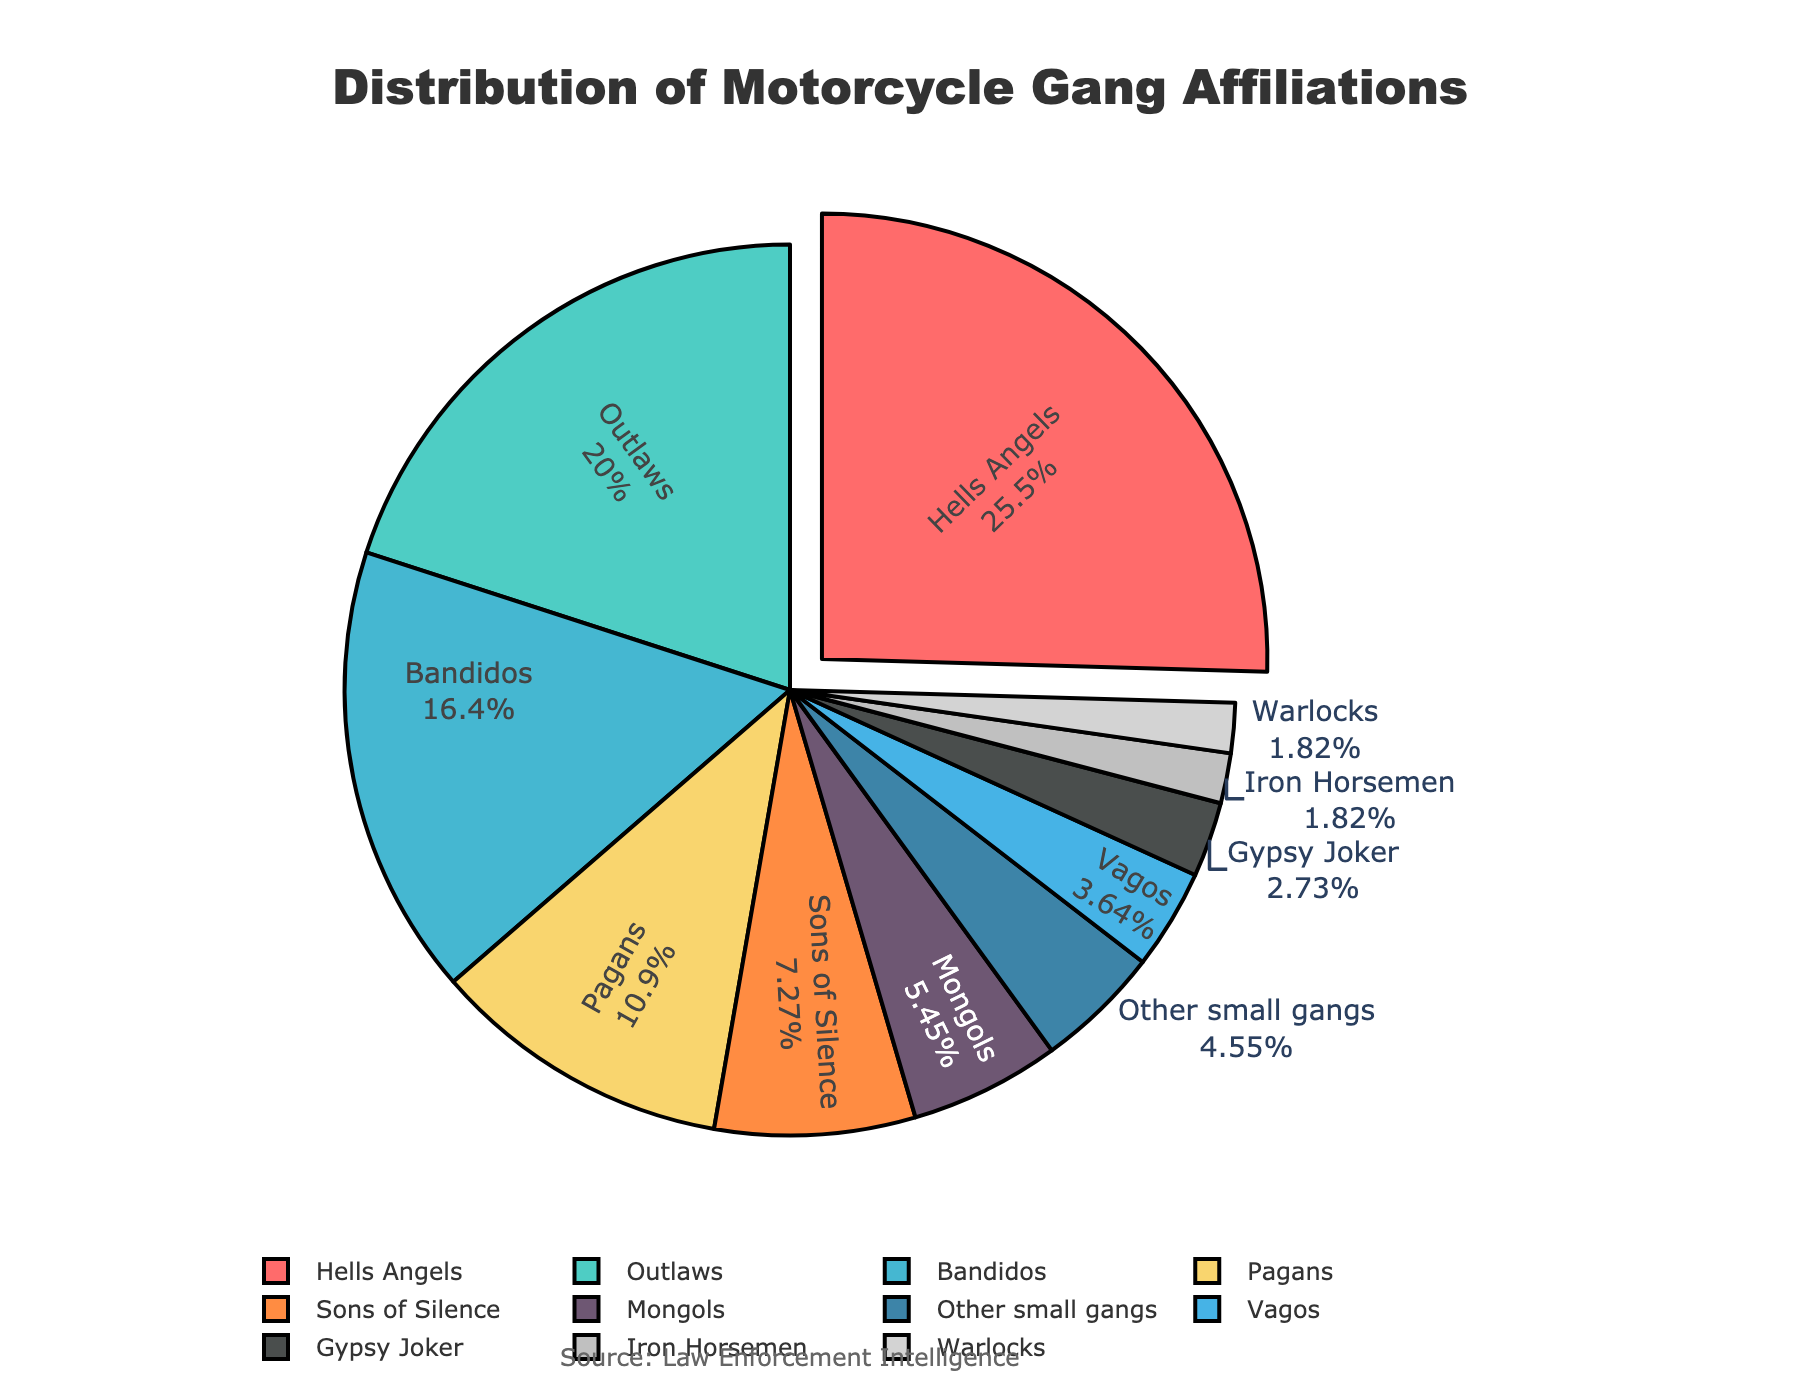What is the affiliation with the highest percentage? The largest slice in the pie chart corresponds to the affiliation with the highest percentage. By observing, we see that "Hells Angels" takes up the biggest portion of the pie.
Answer: Hells Angels How much larger is the percentage of Hells Angels compared to the smallest gang listed? Hells Angels have 28% while the smallest gangs listed, Iron Horsemen and Warlocks, both have 2%. The difference is calculated as 28% - 2%.
Answer: 26% Which gang affiliations together make up more than 50% of the total? Adding up the percentages of gang affiliations starting from the largest: Hells Angels (28%) + Outlaws (22%) = 50%. Since they exactly meet 50%, no more gangs are needed.
Answer: Hells Angels, Outlaws If you combine the percentages of the three smallest gangs, what is their total? The three smallest gangs listed are Gypsy Joker (3%), Iron Horsemen (2%), and Warlocks (2%). Adding them up: 3% + 2% + 2% = 7%.
Answer: 7% Which gang affiliation represents a smaller percentage, Pagans or Mongols? By looking at the pie chart, Pagans have 12% and Mongols have 6%. Comparing these values, Mongols have a smaller percentage.
Answer: Mongols How many gang affiliations have a percentage greater than or equal to 10%? Observing the labels in the pie chart, we see Hells Angels (28%), Outlaws (22%), Bandidos (18%), and Pagans (12%) all have percentages greater than or equal to 10%.
Answer: 4 What percentage of the total do the Bandidos and the Sons of Silence together represent? Adding the percentages of Bandidos (18%) and Sons of Silence (8%): 18% + 8% = 26%.
Answer: 26% What color represents the Outlaws in the pie chart? Visually inspecting the chart, the slice representing Outlaws is colored in turquoise/greenish-blue.
Answer: Turquoise Is the combined percentage of Mongols and Vagos greater than that of Pagans? Mongols have 6% and Vagos have 4%, giving a total of 6% + 4% = 10%. Pagans have 12%. Therefore, 10% is less than 12%.
Answer: No Which gangs together make up about a quarter of the total affiliations? Reviewing the available information in smaller affiliations, we add Sons of Silence (8%), Mongols (6%), Vagos (4%), Gypsy Joker (3%), Iron Horsemen (2%), and Warlocks (2%), which sum to 25%.
Answer: Sons of Silence, Mongols, Vagos, Gypsy Joker, Iron Horsemen, Warlocks 